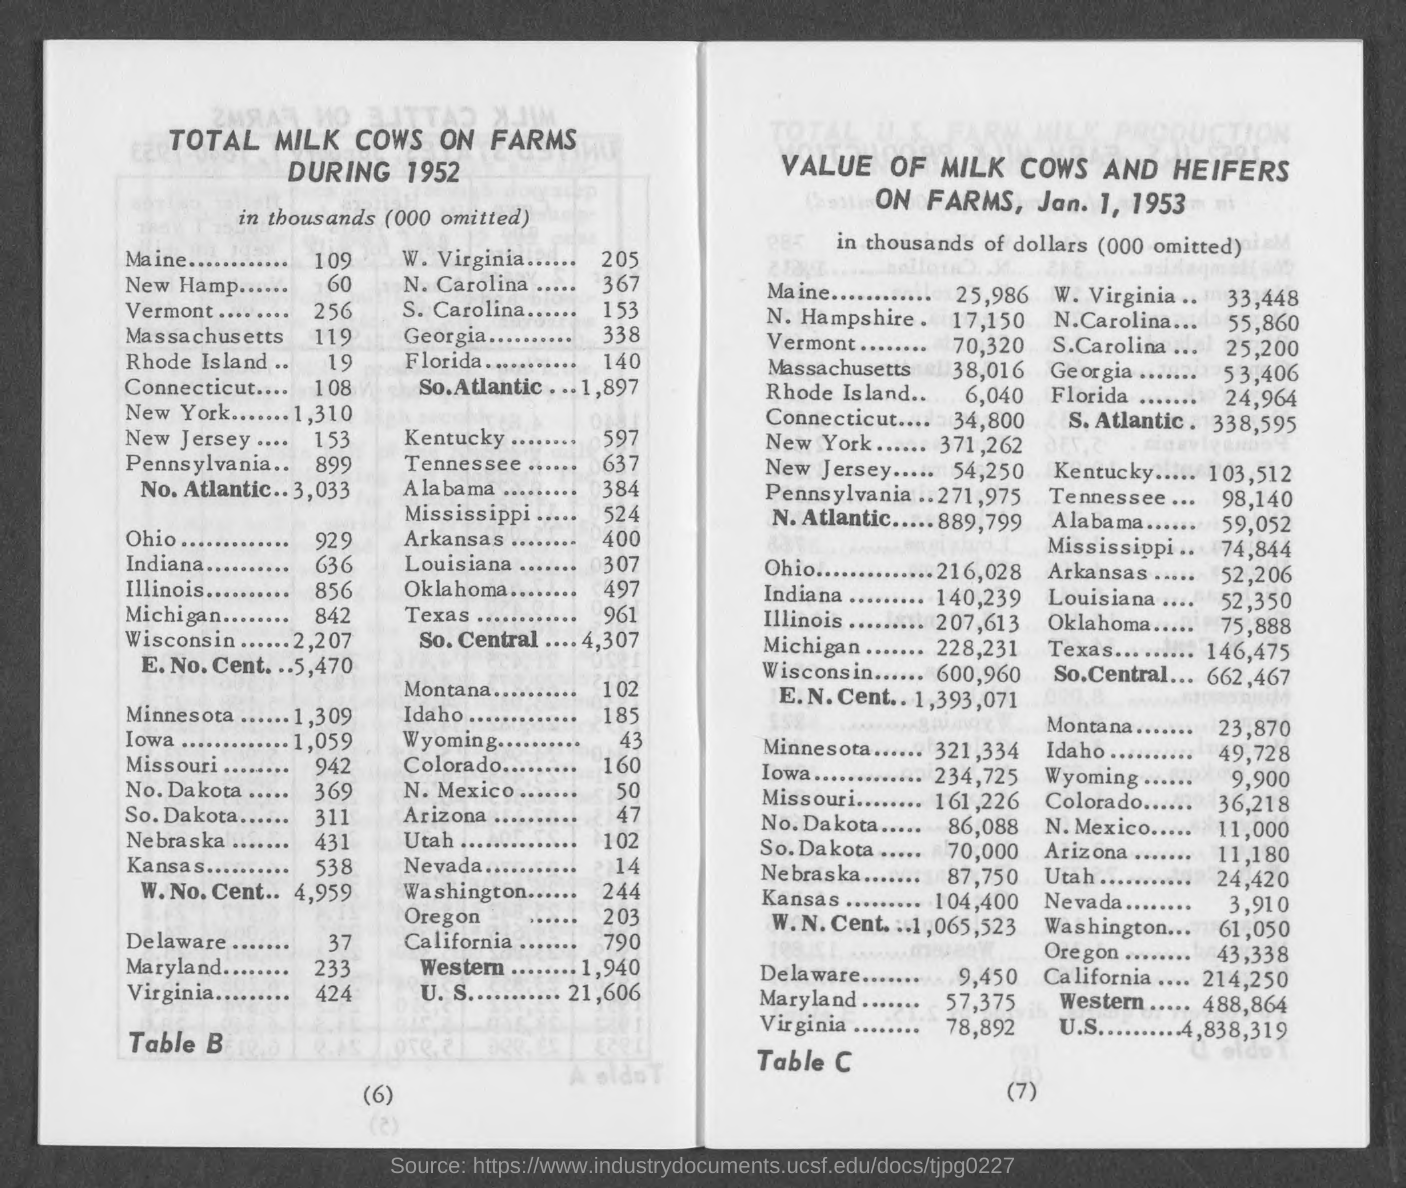What is the total milk cows on farms during 1952 in thousands in maine ?
Your response must be concise. 109. What is the total milk cows on farms during 1952 in thousands in new hamp?
Make the answer very short. 60. What is the total milk cows on farms during 1952 in thousands in vermont ?
Give a very brief answer. 256. What is the total milk cows on farms during 1952 in thousands in massachusetts ?
Provide a succinct answer. 119. What is the total milk cows on farms during 1952 in thousands in rhode island ?
Your response must be concise. 19. What is the total milk cows on farms during 1952 in thousands in connecticut ?
Provide a short and direct response. 108. What is the total milk cows on farms during 1952 in thousands in new york?
Keep it short and to the point. 1,310. What is the total milk cows on farms during 1952 in thousands in new jersey ?
Provide a short and direct response. 153. What is the total milk cows on farms during 1952 in thousands in pennsylvania?
Give a very brief answer. 899. What is the total milk cows on farms during 1952 in thousands in ohio?
Provide a succinct answer. 929. 